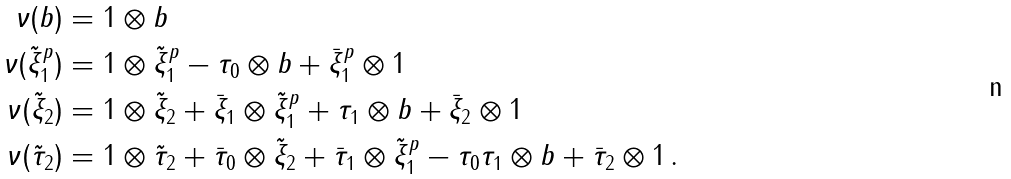Convert formula to latex. <formula><loc_0><loc_0><loc_500><loc_500>\nu ( b ) & = 1 \otimes b \\ \nu ( \tilde { \xi } _ { 1 } ^ { p } ) & = 1 \otimes \tilde { \xi } _ { 1 } ^ { p } - \tau _ { 0 } \otimes b + \bar { \xi } _ { 1 } ^ { p } \otimes 1 \\ \nu ( \tilde { \xi } _ { 2 } ) & = 1 \otimes \tilde { \xi } _ { 2 } + \bar { \xi } _ { 1 } \otimes \tilde { \xi } _ { 1 } ^ { p } + \tau _ { 1 } \otimes b + \bar { \xi } _ { 2 } \otimes 1 \\ \nu ( \tilde { \tau } _ { 2 } ) & = 1 \otimes \tilde { \tau } _ { 2 } + \bar { \tau } _ { 0 } \otimes \tilde { \xi } _ { 2 } + \bar { \tau } _ { 1 } \otimes \tilde { \xi } _ { 1 } ^ { p } - \tau _ { 0 } \tau _ { 1 } \otimes b + \bar { \tau } _ { 2 } \otimes 1 \, .</formula> 